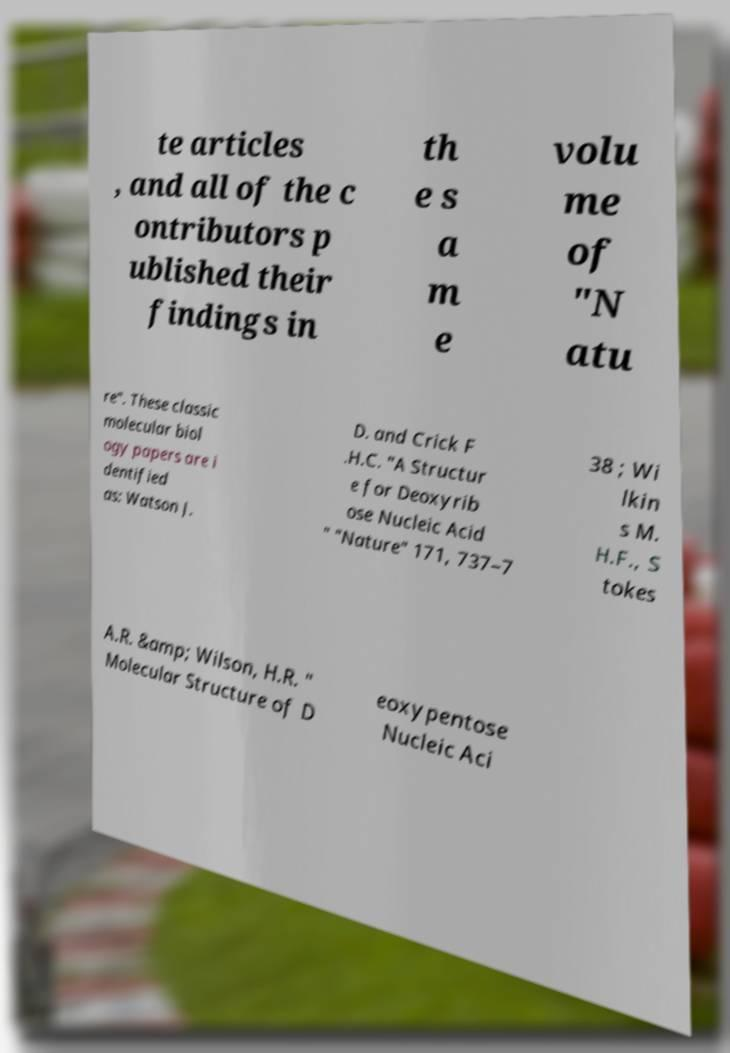Can you read and provide the text displayed in the image?This photo seems to have some interesting text. Can you extract and type it out for me? te articles , and all of the c ontributors p ublished their findings in th e s a m e volu me of "N atu re". These classic molecular biol ogy papers are i dentified as: Watson J. D. and Crick F .H.C. "A Structur e for Deoxyrib ose Nucleic Acid " "Nature" 171, 737–7 38 ; Wi lkin s M. H.F., S tokes A.R. &amp; Wilson, H.R. " Molecular Structure of D eoxypentose Nucleic Aci 